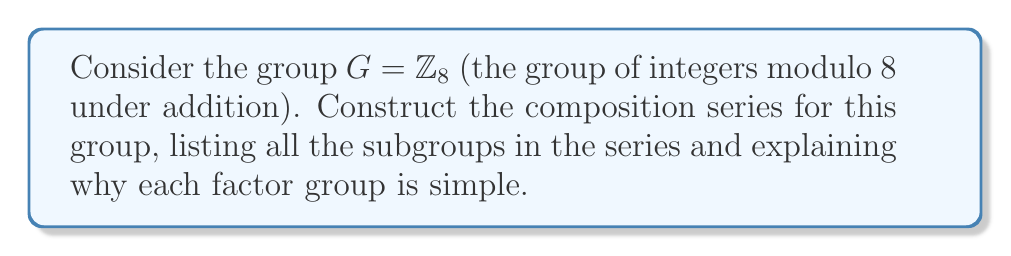Give your solution to this math problem. To construct the composition series for $G = \mathbb{Z}_8$, we need to find a series of normal subgroups where each factor group is simple (has no non-trivial normal subgroups). Let's approach this step-by-step:

1) First, note that $\mathbb{Z}_8$ is an abelian group, so all its subgroups are normal.

2) The subgroups of $\mathbb{Z}_8$ are:
   $\{0\}$, $\{0,4\}$, $\{0,2,4,6\}$, and $\mathbb{Z}_8$ itself.

3) We start with $G = \mathbb{Z}_8$ and work our way down to $\{0\}$:

   $\mathbb{Z}_8 \supset \{0,2,4,6\} \supset \{0,4\} \supset \{0\}$

4) Now, let's check if each factor group is simple:

   a) $\mathbb{Z}_8 / \{0,2,4,6\} \cong \mathbb{Z}_2$
      This is isomorphic to $\mathbb{Z}_2$, which is simple as it has prime order.

   b) $\{0,2,4,6\} / \{0,4\} \cong \mathbb{Z}_2$
      This is also isomorphic to $\mathbb{Z}_2$, which is simple.

   c) $\{0,4\} / \{0\} \cong \mathbb{Z}_2$
      Once again, this is isomorphic to $\mathbb{Z}_2$, which is simple.

5) Therefore, the composition series is:

   $\{0\} \triangleleft \{0,4\} \triangleleft \{0,2,4,6\} \triangleleft \mathbb{Z}_8$

   Where $\triangleleft$ denotes "is a normal subgroup of".

Each factor group in this series is isomorphic to $\mathbb{Z}_2$, which is simple because it has prime order. This confirms that we have indeed constructed a composition series for $\mathbb{Z}_8$.
Answer: The composition series for $\mathbb{Z}_8$ is:

$\{0\} \triangleleft \{0,4\} \triangleleft \{0,2,4,6\} \triangleleft \mathbb{Z}_8$

with factor groups all isomorphic to $\mathbb{Z}_2$. 